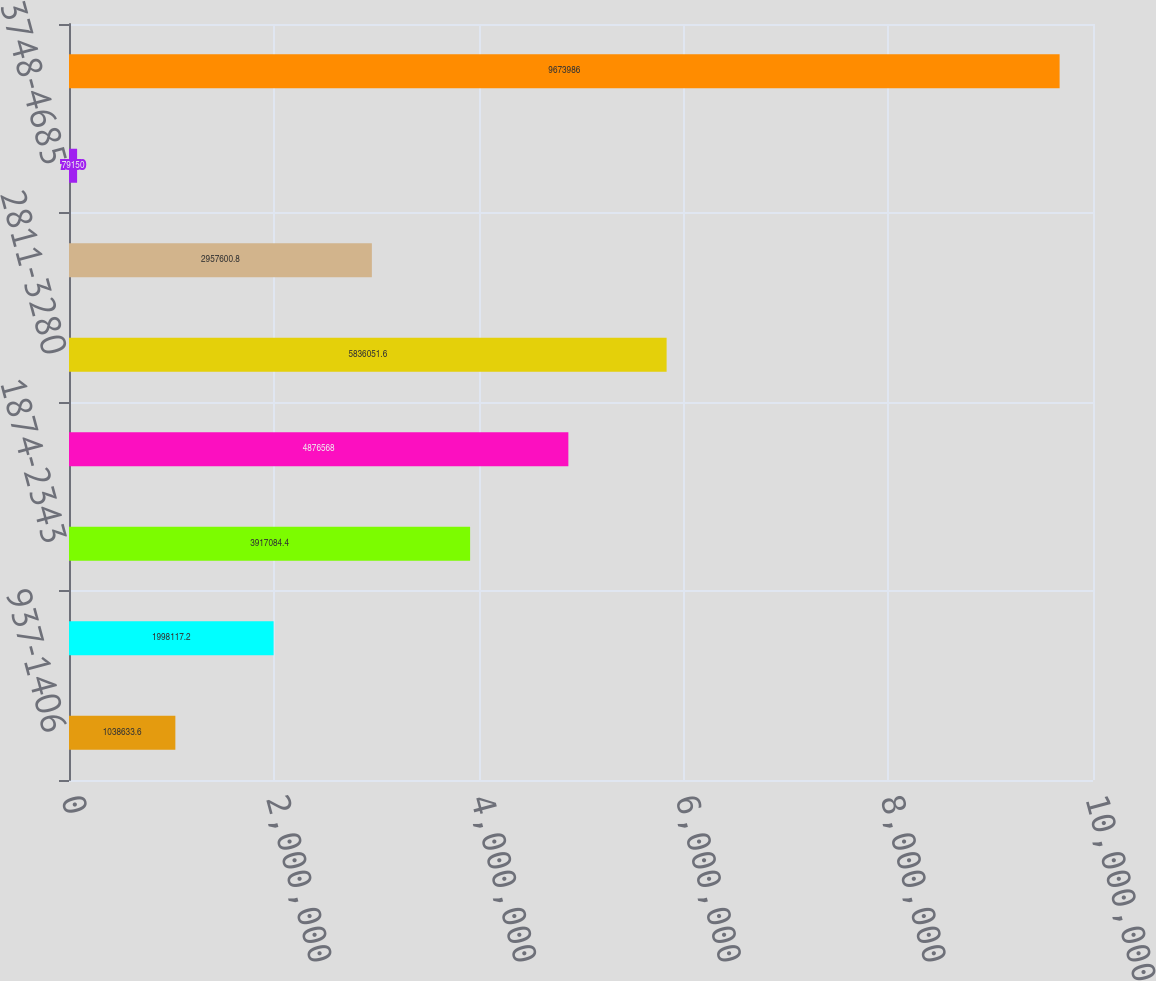Convert chart to OTSL. <chart><loc_0><loc_0><loc_500><loc_500><bar_chart><fcel>937-1406<fcel>1406-1874<fcel>1874-2343<fcel>2343-2811<fcel>2811-3280<fcel>3280-3748<fcel>3748-4685<fcel>Total<nl><fcel>1.03863e+06<fcel>1.99812e+06<fcel>3.91708e+06<fcel>4.87657e+06<fcel>5.83605e+06<fcel>2.9576e+06<fcel>79150<fcel>9.67399e+06<nl></chart> 